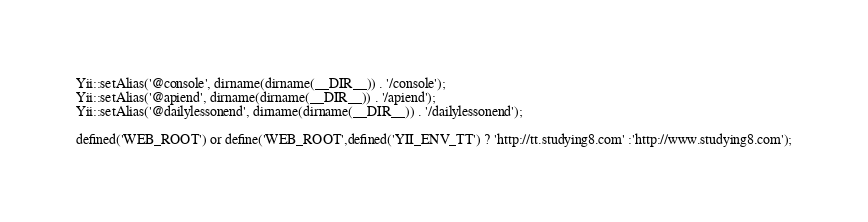<code> <loc_0><loc_0><loc_500><loc_500><_PHP_>Yii::setAlias('@console', dirname(dirname(__DIR__)) . '/console');
Yii::setAlias('@apiend', dirname(dirname(__DIR__)) . '/apiend');
Yii::setAlias('@dailylessonend', dirname(dirname(__DIR__)) . '/dailylessonend');

defined('WEB_ROOT') or define('WEB_ROOT',defined('YII_ENV_TT') ? 'http://tt.studying8.com' :'http://www.studying8.com');</code> 